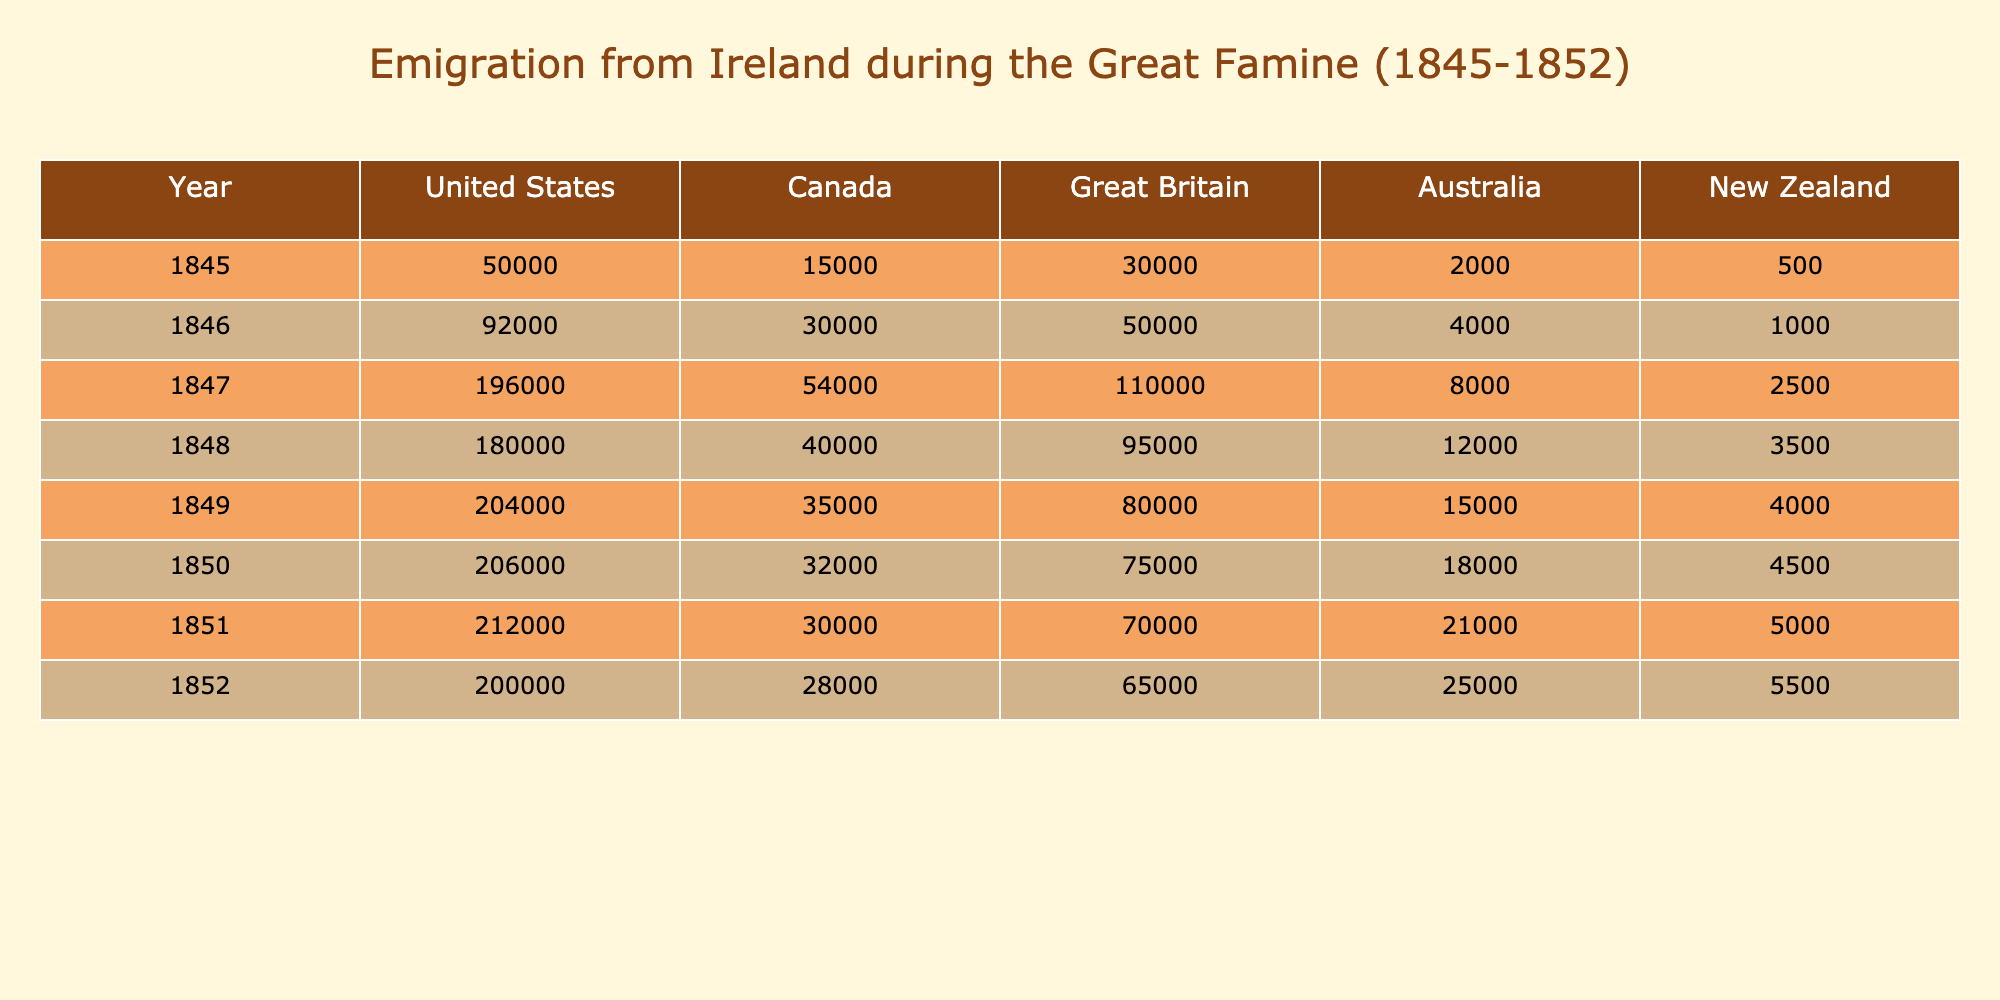What was the total number of emigrants from Ireland to the United States in 1847? The table shows that in 1847, the number of emigrants from Ireland to the United States was listed as 196,000.
Answer: 196000 What country received the second highest number of Irish emigrants in 1850? In 1850, the number of emigrants to the United States was 206,000, to Canada was 32,000, to Great Britain was 75,000, to Australia was 18,000, and to New Zealand was 4,500. The second highest number of emigrants is to Great Britain, with 75,000.
Answer: Great Britain How many more emigrants left for the United States in 1849 compared to Canada? In 1849, the number of emigrants to the United States was 204,000 and to Canada was 35,000. Subtracting these gives 204,000 - 35,000 = 169,000.
Answer: 169000 What is the average number of emigrants from Ireland to Australia from 1845 to 1852? The numbers for Australia are 2,000 in 1845, 4,000 in 1846, 8,000 in 1847, 12,000 in 1848, 15,000 in 1849, 18,000 in 1850, 21,000 in 1851, and 25,000 in 1852. Adding these gives 2,000 + 4,000 + 8,000 + 12,000 + 15,000 + 18,000 + 21,000 + 25,000 = 105,000. Dividing by 8 (the number of years) gives 105,000 / 8 = 13,125.
Answer: 13125 During which year did the highest number of Irish emigrants travel to Canada? Referring to the table, the number of emigrants to Canada peaked at 54,000 in 1847.
Answer: 1847 Is it true that the number of emigrants to New Zealand in 1852 was greater than that in 1846? The table indicates 5,500 emigrants to New Zealand in 1852 and 1,000 in 1846. Since 5,500 is greater than 1,000, it is true.
Answer: Yes What was the change in the number of emigrants from Ireland to the United States from 1845 to 1852? In 1845, there were 50,000 emigrants to the United States and in 1852 there were 200,000. The change is calculated by taking 200,000 - 50,000 = 150,000.
Answer: 150000 Identify the year with the lowest total emigration to Australia during the Great Famine. The table shows the number of emigrants to Australia as 2,000 in 1845, 4,000 in 1846, 8,000 in 1847, 12,000 in 1848, 15,000 in 1849, 18,000 in 1850, 21,000 in 1851, and 25,000 in 1852. The lowest value is 2,000 in 1845.
Answer: 1845 What was the total number of emigrants from Ireland to Great Britain over the entire period of the Great Famine? The table shows the following numbers for Great Britain: 30,000 (1845) + 50,000 (1846) + 110,000 (1847) + 95,000 (1848) + 80,000 (1849) + 75,000 (1850) + 70,000 (1851) + 65,000 (1852) = 650,000.
Answer: 650000 Which country saw a decrease in the number of Irish emigrants from 1847 to 1848? Looking at the table, the numbers for the United States were 196,000 in 1847 and 180,000 in 1848, indicating a decrease.
Answer: United States 